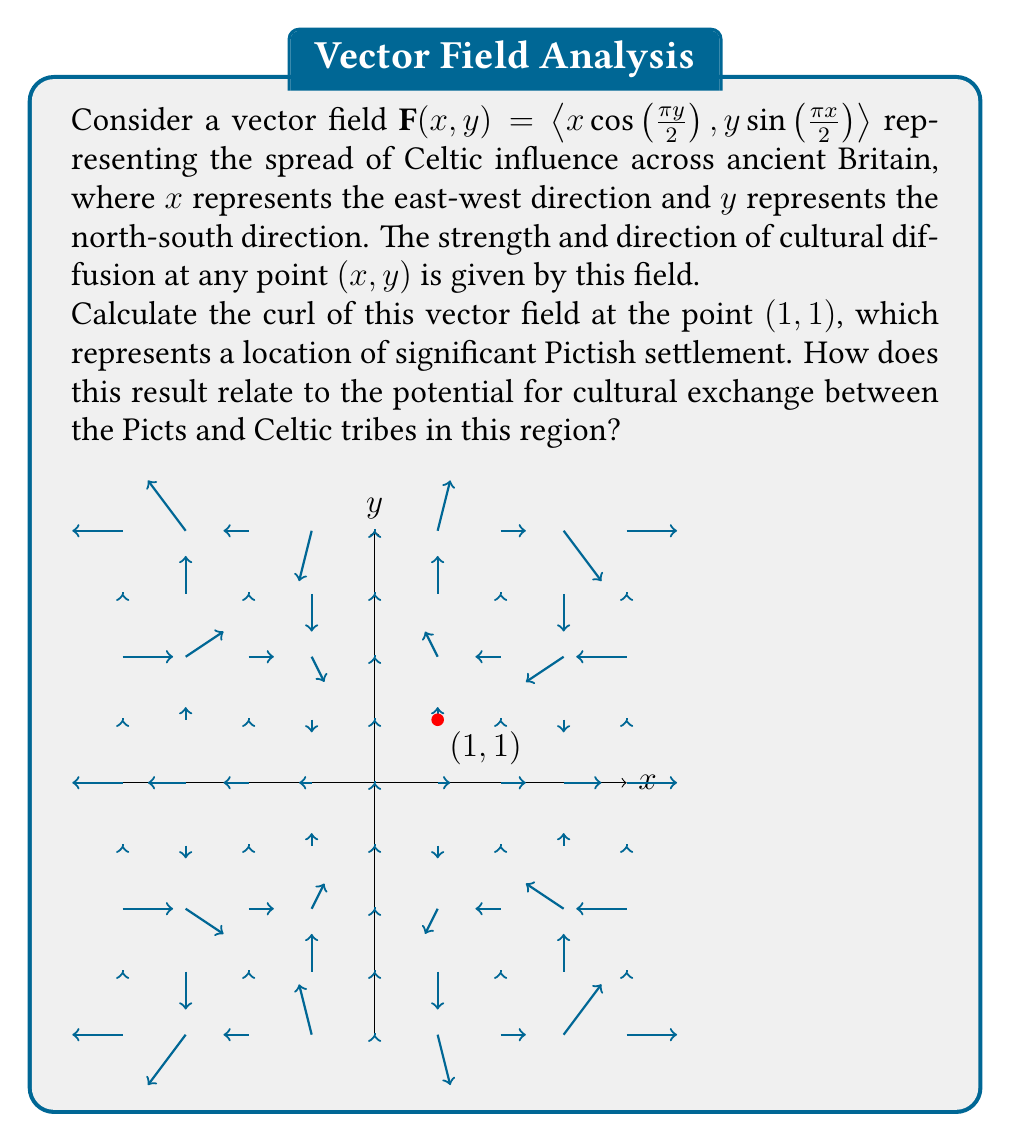Help me with this question. To solve this problem, we need to follow these steps:

1) The curl of a vector field $\mathbf{F}(x,y) = \langle P(x,y), Q(x,y) \rangle$ in two dimensions is given by:

   $$\text{curl }\mathbf{F} = \frac{\partial Q}{\partial x} - \frac{\partial P}{\partial y}$$

2) In our case, $P(x,y) = x\cos(\frac{\pi y}{2})$ and $Q(x,y) = y\sin(\frac{\pi x}{2})$

3) Let's calculate $\frac{\partial Q}{\partial x}$:
   $$\frac{\partial Q}{\partial x} = y \cdot \frac{\pi}{2} \cos(\frac{\pi x}{2})$$

4) Now, let's calculate $\frac{\partial P}{\partial y}$:
   $$\frac{\partial P}{\partial y} = x \cdot (-\frac{\pi}{2}) \sin(\frac{\pi y}{2})$$

5) The curl is the difference of these partial derivatives:
   $$\text{curl }\mathbf{F} = y \cdot \frac{\pi}{2} \cos(\frac{\pi x}{2}) - x \cdot (-\frac{\pi}{2}) \sin(\frac{\pi y}{2})$$
   $$= \frac{\pi}{2} [y \cos(\frac{\pi x}{2}) + x \sin(\frac{\pi y}{2})]$$

6) Now, we evaluate this at the point (1,1):
   $$\text{curl }\mathbf{F}(1,1) = \frac{\pi}{2} [1 \cdot \cos(\frac{\pi}{2}) + 1 \cdot \sin(\frac{\pi}{2})]$$
   $$= \frac{\pi}{2} [0 + 1] = \frac{\pi}{2}$$

7) Interpretation: The positive curl at (1,1) indicates a counterclockwise rotation in the cultural influence at this point. This suggests that at this Pictish settlement, there is a tendency for Celtic cultural elements to circulate and potentially be absorbed. The magnitude $\frac{\pi}{2} \approx 1.57$ indicates a moderate strength of this cultural mixing, implying a significant potential for cultural exchange between the Picts and Celtic tribes in this region.
Answer: $\frac{\pi}{2}$ 